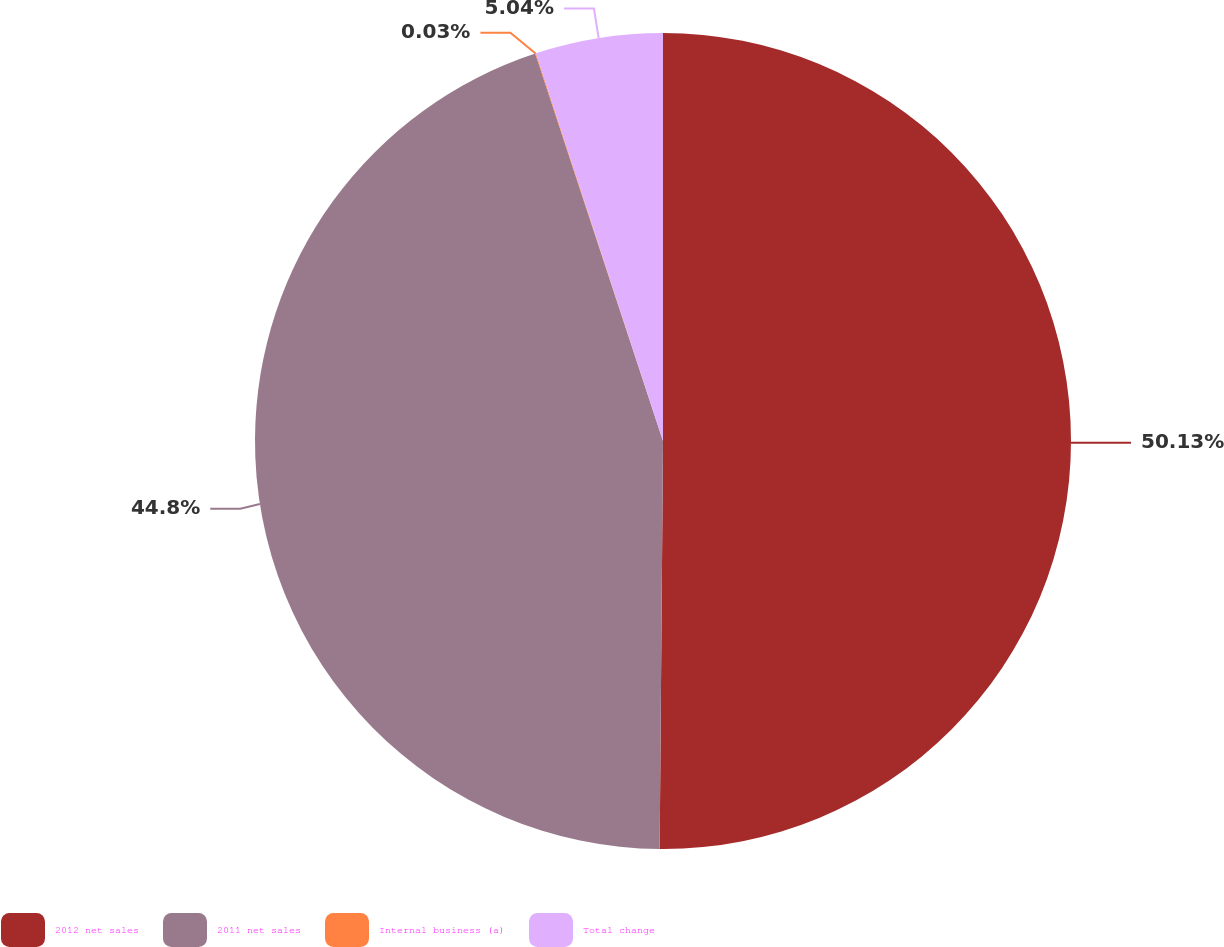Convert chart to OTSL. <chart><loc_0><loc_0><loc_500><loc_500><pie_chart><fcel>2012 net sales<fcel>2011 net sales<fcel>Internal business (a)<fcel>Total change<nl><fcel>50.13%<fcel>44.8%<fcel>0.03%<fcel>5.04%<nl></chart> 